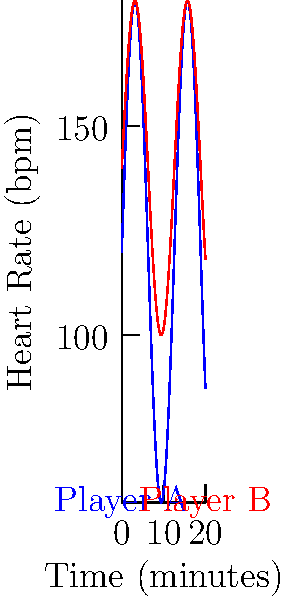Based on the heart rate graphs of two players during a match, which player is more likely to experience fatigue earlier? To determine which player is more likely to experience fatigue earlier, we need to analyze the heart rate patterns:

1. Player A (blue line):
   - Heart rate range: Approximately 60-180 bpm
   - Average heart rate: Around 120 bpm

2. Player B (red line):
   - Heart rate range: Approximately 100-180 bpm
   - Average heart rate: Around 140 bpm

3. Factors indicating earlier fatigue:
   - Higher average heart rate
   - Less recovery time (fewer dips in the heart rate)

4. Comparison:
   - Player B has a consistently higher heart rate throughout the match
   - Player B's heart rate doesn't drop as low as Player A's during recovery periods

5. Physiological implications:
   - Higher heart rates indicate greater cardiovascular stress
   - Less recovery time leads to accumulation of fatigue

6. Conclusion:
   Player B is more likely to experience fatigue earlier due to the higher average heart rate and less recovery time between intense periods.
Answer: Player B 